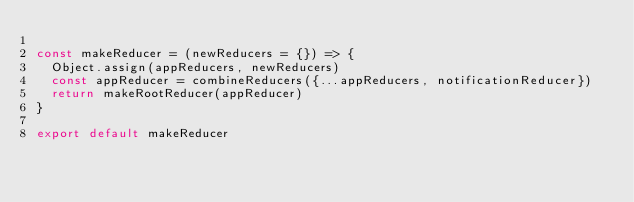Convert code to text. <code><loc_0><loc_0><loc_500><loc_500><_TypeScript_>
const makeReducer = (newReducers = {}) => {
  Object.assign(appReducers, newReducers)
  const appReducer = combineReducers({...appReducers, notificationReducer})
  return makeRootReducer(appReducer)
}

export default makeReducer
</code> 